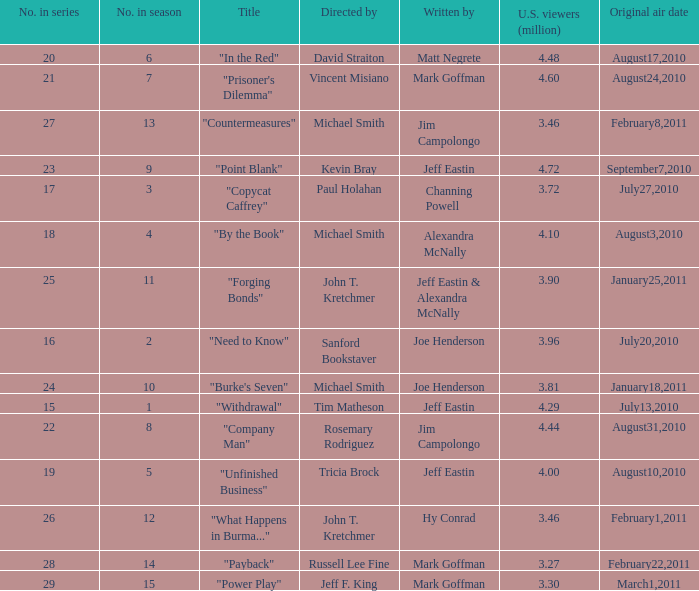Who directed the episode "Point Blank"? Kevin Bray. 